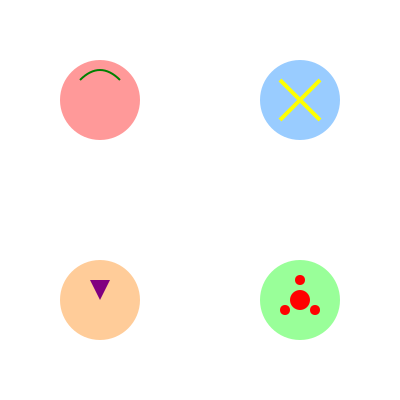Match the abstract garnish patterns shown in the image to their corresponding cocktail recipes:

A. Mojito
B. Tequila Sunrise
C. Whiskey Sour
D. Cherry Blossom Martini

Which pattern corresponds to the Cherry Blossom Martini? To solve this visual challenge, we need to analyze each pattern and match it to the most likely cocktail based on the garnish representation:

1. Top-left (pink circle with green curve):
   - The green curve suggests a lime or mint leaf, common in Mojitos.
   - This pattern likely represents a Mojito.

2. Top-right (blue circle with yellow X):
   - The yellow X could represent sliced citrus, often used in Whiskey Sours.
   - This pattern likely represents a Whiskey Sour.

3. Bottom-left (orange circle with purple triangle):
   - The triangle shape and colors suggest a sunrise effect, typical of a Tequila Sunrise.
   - This pattern likely represents a Tequila Sunrise.

4. Bottom-right (green circle with red dots):
   - The red dots in a flower-like arrangement suggest cherry blossoms.
   - This pattern likely represents a Cherry Blossom Martini.

By process of elimination and matching the visual representations to the cocktail names, we can conclude that the bottom-right pattern (green circle with red dots) corresponds to the Cherry Blossom Martini.
Answer: Bottom-right pattern 